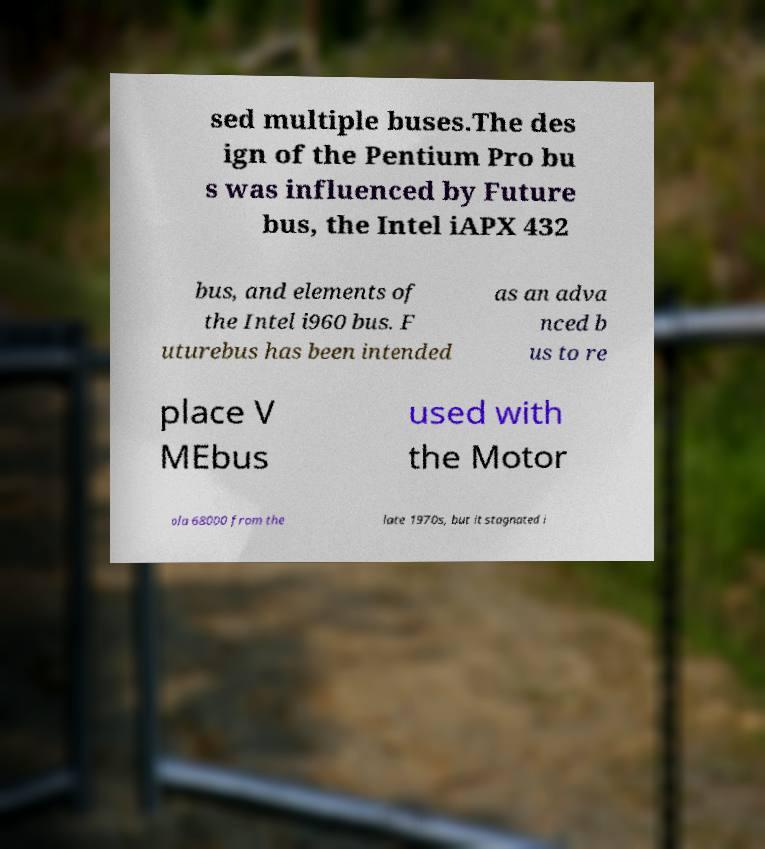Please identify and transcribe the text found in this image. sed multiple buses.The des ign of the Pentium Pro bu s was influenced by Future bus, the Intel iAPX 432 bus, and elements of the Intel i960 bus. F uturebus has been intended as an adva nced b us to re place V MEbus used with the Motor ola 68000 from the late 1970s, but it stagnated i 